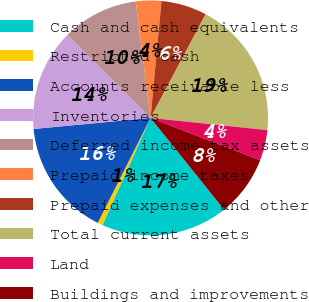Convert chart to OTSL. <chart><loc_0><loc_0><loc_500><loc_500><pie_chart><fcel>Cash and cash equivalents<fcel>Restricted cash<fcel>Accounts receivable less<fcel>Inventories<fcel>Deferred income tax assets<fcel>Prepaid income taxes<fcel>Prepaid expenses and other<fcel>Total current assets<fcel>Land<fcel>Buildings and improvements<nl><fcel>17.48%<fcel>0.7%<fcel>16.08%<fcel>13.99%<fcel>10.49%<fcel>3.5%<fcel>6.29%<fcel>18.88%<fcel>4.2%<fcel>8.39%<nl></chart> 